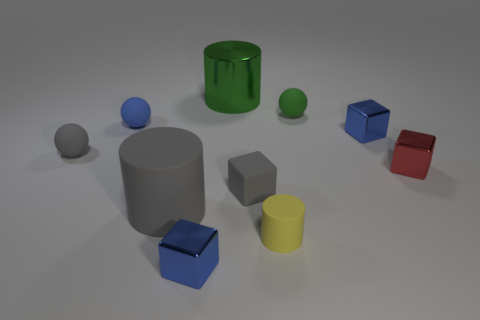There is a tiny blue thing in front of the gray matte cylinder; what is its material?
Your answer should be compact. Metal. Are there fewer big purple matte cylinders than large green objects?
Your answer should be compact. Yes. There is a small red object; is its shape the same as the small blue metallic object that is in front of the large gray cylinder?
Your answer should be very brief. Yes. The thing that is both behind the blue matte object and on the right side of the tiny yellow object has what shape?
Provide a short and direct response. Sphere. Are there the same number of small red metallic objects on the left side of the large metallic object and blue shiny blocks that are right of the tiny gray matte sphere?
Your answer should be very brief. No. There is a tiny blue object that is in front of the tiny yellow rubber thing; is it the same shape as the yellow matte object?
Keep it short and to the point. No. How many green objects are big rubber blocks or small matte balls?
Keep it short and to the point. 1. What is the material of the small object that is the same shape as the large gray thing?
Keep it short and to the point. Rubber. What shape is the tiny blue metallic object left of the tiny matte cube?
Your answer should be compact. Cube. Is there a large gray ball made of the same material as the yellow cylinder?
Your response must be concise. No. 